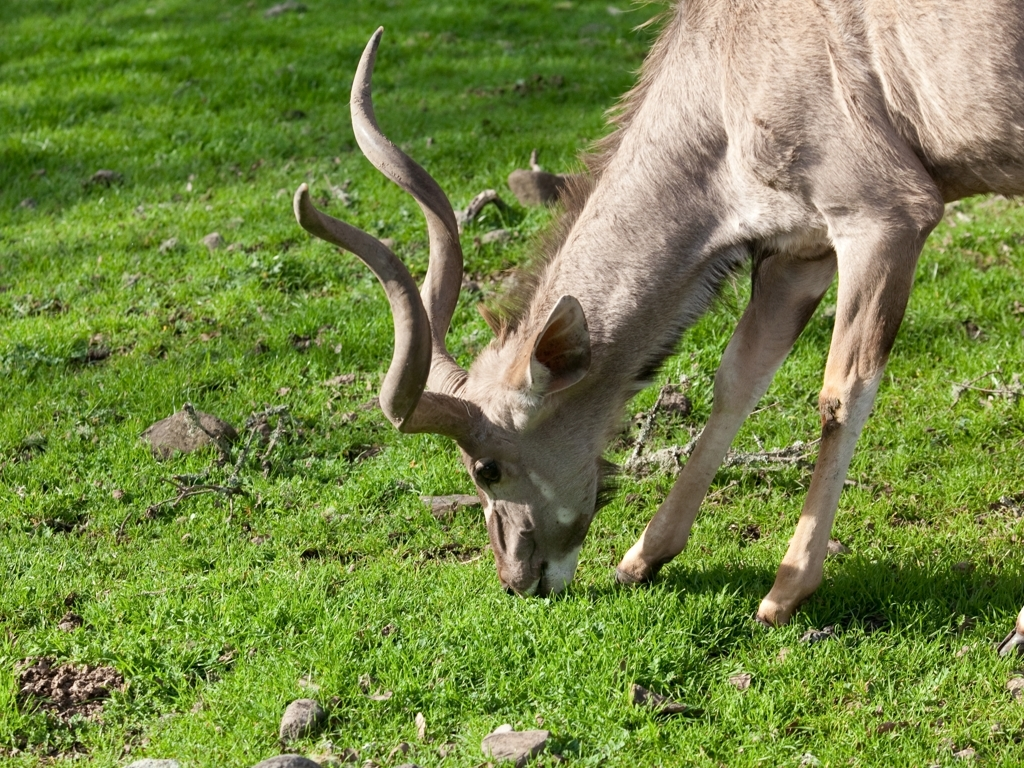Can you tell me about the species or notable features of this deer? While the exact species cannot be confirmed without more context, the deer has a set of antlers with a distinctive curvature, which suggests it may be a male from a species such as a Red deer or an Elk, known for antlers that shed and regrow annually. 